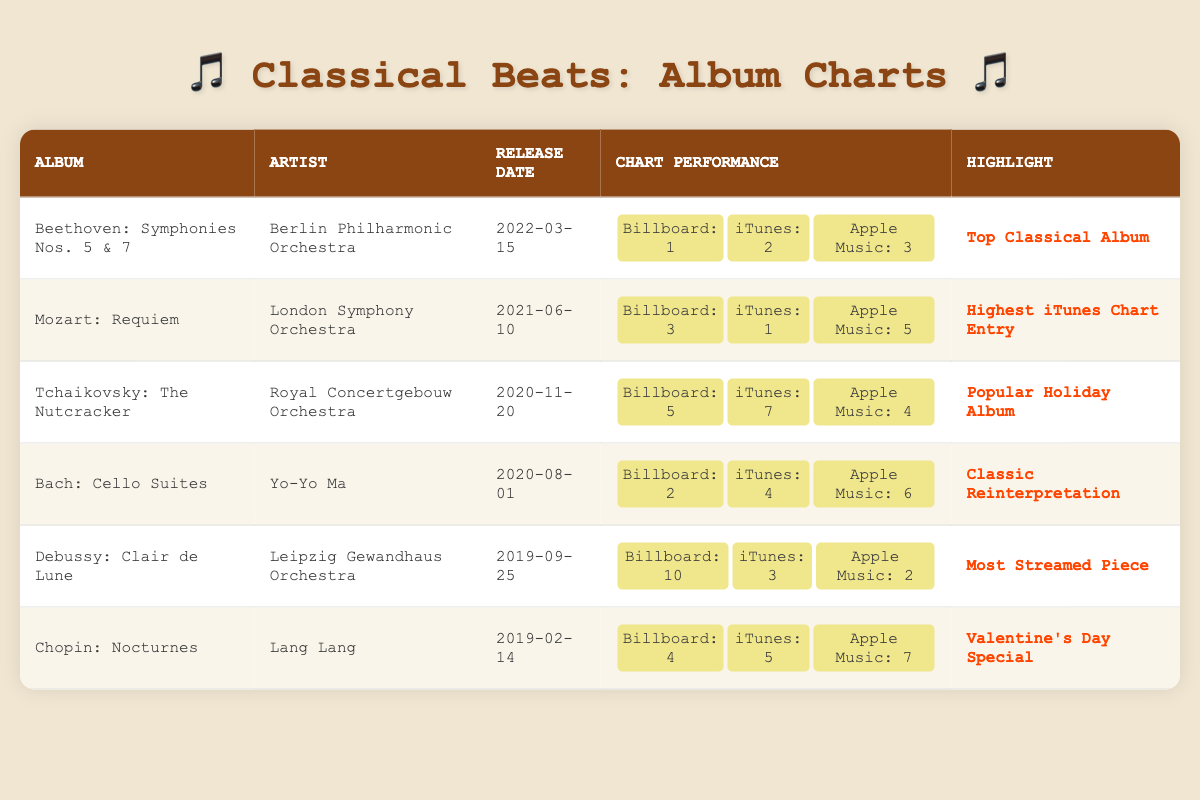What is the release date of "Mozart: Requiem"? The table lists the release dates of each album, and "Mozart: Requiem" is associated with the release date "2021-06-10".
Answer: 2021-06-10 Which album has the highest Billboard chart position? By looking at the Billboard chart positions, "Beethoven: Symphonies Nos. 5 & 7" is at position 1, which is the highest compared to other albums listed.
Answer: Beethoven: Symphonies Nos. 5 & 7 Is "Chopin: Nocturnes" highly ranked on iTunes? The iTunes chart position for "Chopin: Nocturnes" is 5, not 1 or 2, so it is not in the top ranks.
Answer: No Which two albums were released in 2020? Scanning the release dates, "Tchaikovsky: The Nutcracker" was released on 2020-11-20 and "Bach: Cello Suites" was released on 2020-08-01. So, both albums are from 2020.
Answer: Tchaikovsky: The Nutcracker and Bach: Cello Suites What is the average iTunes position of the albums in the table? The iTunes chart positions are 2, 1, 7, 4, 3, and 5 (for 6 albums). Summing them gives 2 + 1 + 7 + 4 + 3 + 5 = 22. Dividing by 6 gives an average of 22/6 ≈ 3.67.
Answer: 3.67 Which album was recognized as the "Top Classical Album"? The highlight for "Beethoven: Symphonies Nos. 5 & 7" states it as "Top Classical Album", making it the album with this recognition.
Answer: Beethoven: Symphonies Nos. 5 & 7 What is the difference between the iTunes positions of "Debussy: Clair de Lune" and "Bach: Cello Suites"? The iTunes position for "Debussy: Clair de Lune" is 3 and for "Bach: Cello Suites" is 4. The difference is 4 - 3 = 1.
Answer: 1 Is "Tchaikovsky: The Nutcracker" more popular than "Chopin: Nocturnes" on Apple Music? The Apple Music positions are 4 for "Tchaikovsky: The Nutcracker" and 7 for "Chopin: Nocturnes". Since 4 is lower than 7, "Tchaikovsky: The Nutcracker" is indeed more popular.
Answer: Yes What is the highest ranking any album achieved on Apple Music? The highest ranking on Apple Music is 2 (from "Debussy: Clair de Lune"), as reflected in the chart positions listed for all albums.
Answer: 2 Which artist has the lowest Billboard chart position? The lowest Billboard position is 10 (for "Debussy: Clair de Lune"), making Leipzig Gewandhaus Orchestra the artist associated with this position.
Answer: Leipzig Gewandhaus Orchestra How many albums charted in the top 3 for iTunes? From the iTunes positions, "Mozart: Requiem" (1), "Debussy: Clair de Lune" (3), and "Bach: Cello Suites" (4) make 2 albums that are in the top 3.
Answer: 2 